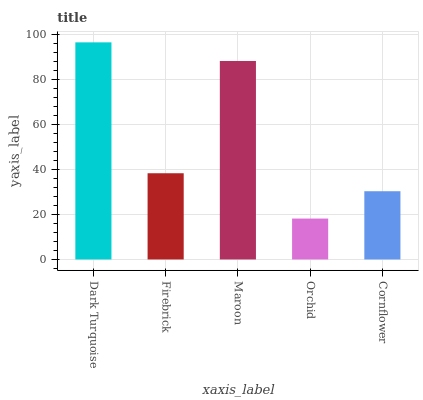Is Orchid the minimum?
Answer yes or no. Yes. Is Dark Turquoise the maximum?
Answer yes or no. Yes. Is Firebrick the minimum?
Answer yes or no. No. Is Firebrick the maximum?
Answer yes or no. No. Is Dark Turquoise greater than Firebrick?
Answer yes or no. Yes. Is Firebrick less than Dark Turquoise?
Answer yes or no. Yes. Is Firebrick greater than Dark Turquoise?
Answer yes or no. No. Is Dark Turquoise less than Firebrick?
Answer yes or no. No. Is Firebrick the high median?
Answer yes or no. Yes. Is Firebrick the low median?
Answer yes or no. Yes. Is Orchid the high median?
Answer yes or no. No. Is Cornflower the low median?
Answer yes or no. No. 